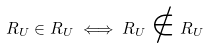Convert formula to latex. <formula><loc_0><loc_0><loc_500><loc_500>R _ { U } \in R _ { U } \iff R _ { U } \notin R _ { U }</formula> 